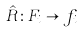Convert formula to latex. <formula><loc_0><loc_0><loc_500><loc_500>\hat { R } \colon F _ { i } \rightarrow f _ { i }</formula> 